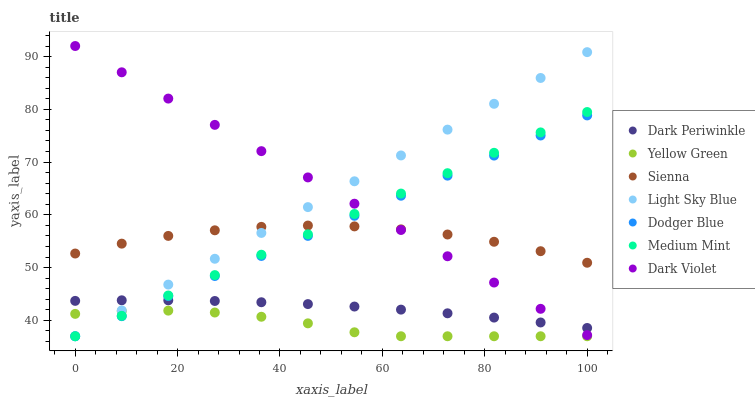Does Yellow Green have the minimum area under the curve?
Answer yes or no. Yes. Does Dark Violet have the maximum area under the curve?
Answer yes or no. Yes. Does Dark Violet have the minimum area under the curve?
Answer yes or no. No. Does Yellow Green have the maximum area under the curve?
Answer yes or no. No. Is Medium Mint the smoothest?
Answer yes or no. Yes. Is Sienna the roughest?
Answer yes or no. Yes. Is Yellow Green the smoothest?
Answer yes or no. No. Is Yellow Green the roughest?
Answer yes or no. No. Does Medium Mint have the lowest value?
Answer yes or no. Yes. Does Dark Violet have the lowest value?
Answer yes or no. No. Does Dark Violet have the highest value?
Answer yes or no. Yes. Does Yellow Green have the highest value?
Answer yes or no. No. Is Yellow Green less than Dark Violet?
Answer yes or no. Yes. Is Dark Periwinkle greater than Yellow Green?
Answer yes or no. Yes. Does Light Sky Blue intersect Dodger Blue?
Answer yes or no. Yes. Is Light Sky Blue less than Dodger Blue?
Answer yes or no. No. Is Light Sky Blue greater than Dodger Blue?
Answer yes or no. No. Does Yellow Green intersect Dark Violet?
Answer yes or no. No. 